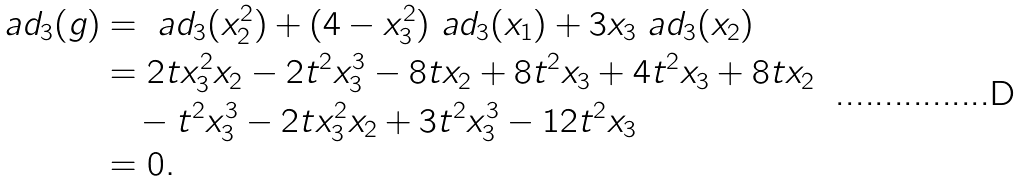<formula> <loc_0><loc_0><loc_500><loc_500>\ a d _ { 3 } ( g ) & = \ a d _ { 3 } ( x _ { 2 } ^ { 2 } ) + ( 4 - x _ { 3 } ^ { 2 } ) \ a d _ { 3 } ( x _ { 1 } ) + 3 x _ { 3 } \ a d _ { 3 } ( x _ { 2 } ) \\ & = 2 t x _ { 3 } ^ { 2 } x _ { 2 } - 2 t ^ { 2 } x _ { 3 } ^ { 3 } - 8 t x _ { 2 } + 8 t ^ { 2 } x _ { 3 } + 4 t ^ { 2 } x _ { 3 } + 8 t x _ { 2 } \\ & \quad - t ^ { 2 } x _ { 3 } ^ { 3 } - 2 t x _ { 3 } ^ { 2 } x _ { 2 } + 3 t ^ { 2 } x _ { 3 } ^ { 3 } - 1 2 t ^ { 2 } x _ { 3 } \\ & = 0 .</formula> 